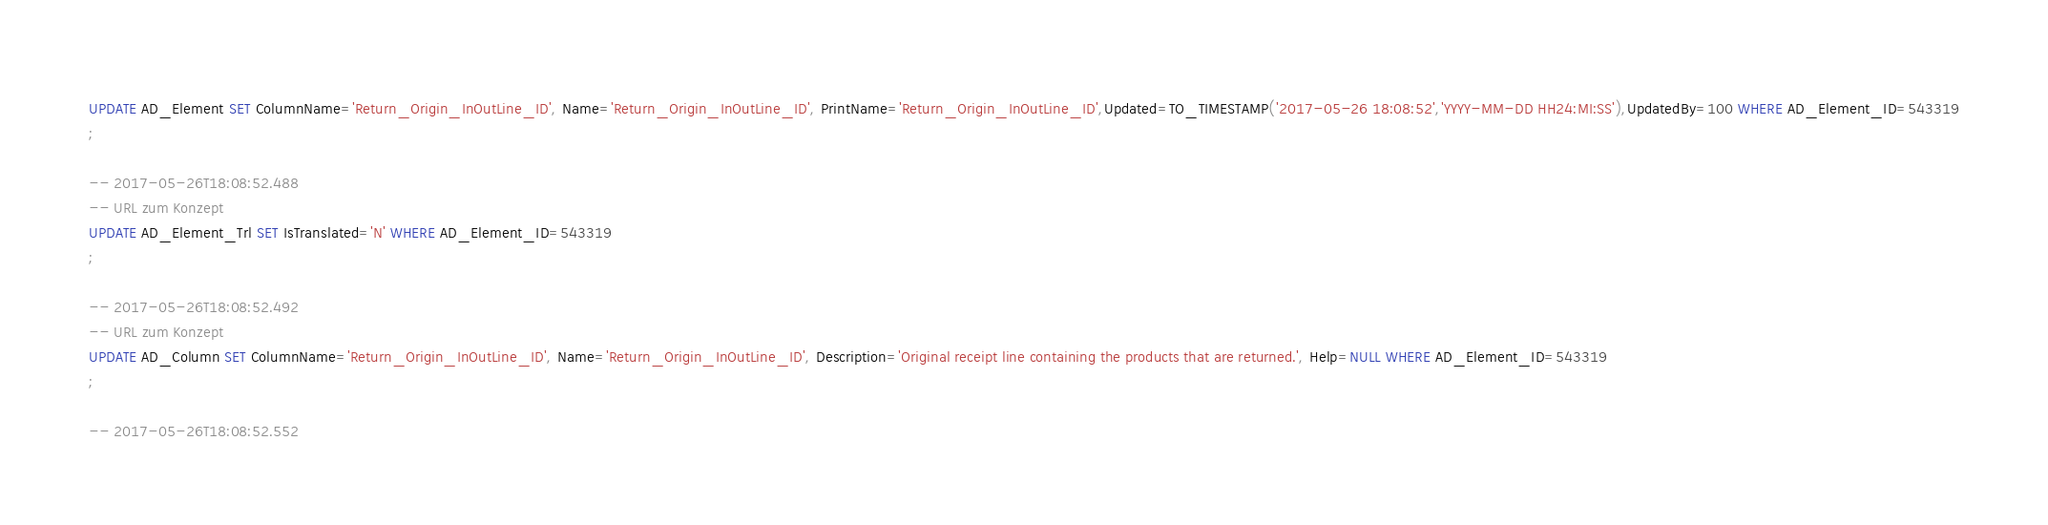Convert code to text. <code><loc_0><loc_0><loc_500><loc_500><_SQL_>UPDATE AD_Element SET ColumnName='Return_Origin_InOutLine_ID', Name='Return_Origin_InOutLine_ID', PrintName='Return_Origin_InOutLine_ID',Updated=TO_TIMESTAMP('2017-05-26 18:08:52','YYYY-MM-DD HH24:MI:SS'),UpdatedBy=100 WHERE AD_Element_ID=543319
;

-- 2017-05-26T18:08:52.488
-- URL zum Konzept
UPDATE AD_Element_Trl SET IsTranslated='N' WHERE AD_Element_ID=543319
;

-- 2017-05-26T18:08:52.492
-- URL zum Konzept
UPDATE AD_Column SET ColumnName='Return_Origin_InOutLine_ID', Name='Return_Origin_InOutLine_ID', Description='Original receipt line containing the products that are returned.', Help=NULL WHERE AD_Element_ID=543319
;

-- 2017-05-26T18:08:52.552</code> 